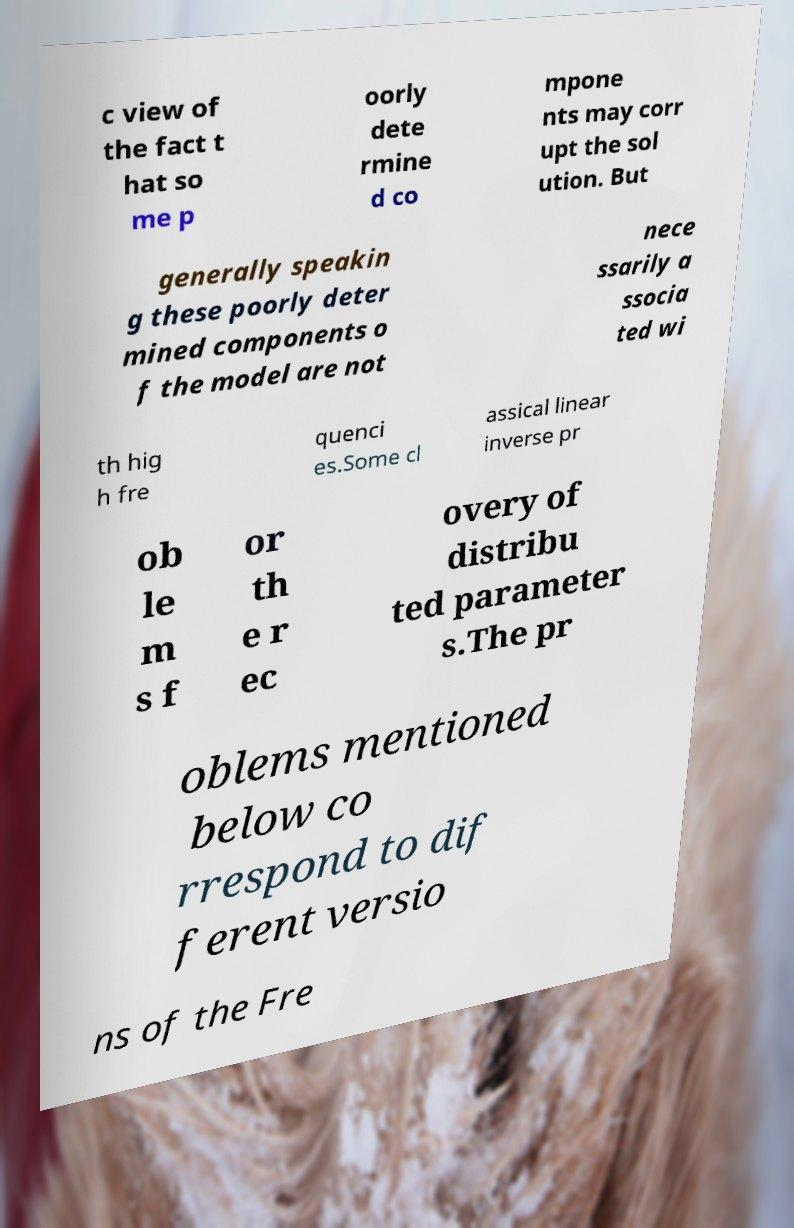What messages or text are displayed in this image? I need them in a readable, typed format. c view of the fact t hat so me p oorly dete rmine d co mpone nts may corr upt the sol ution. But generally speakin g these poorly deter mined components o f the model are not nece ssarily a ssocia ted wi th hig h fre quenci es.Some cl assical linear inverse pr ob le m s f or th e r ec overy of distribu ted parameter s.The pr oblems mentioned below co rrespond to dif ferent versio ns of the Fre 